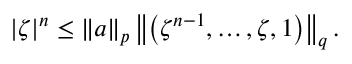Convert formula to latex. <formula><loc_0><loc_0><loc_500><loc_500>| \zeta | ^ { n } \leq \| a \| _ { p } \left \| \left ( \zeta ^ { n - 1 } , \dots , \zeta , 1 \right ) \right \| _ { q } .</formula> 